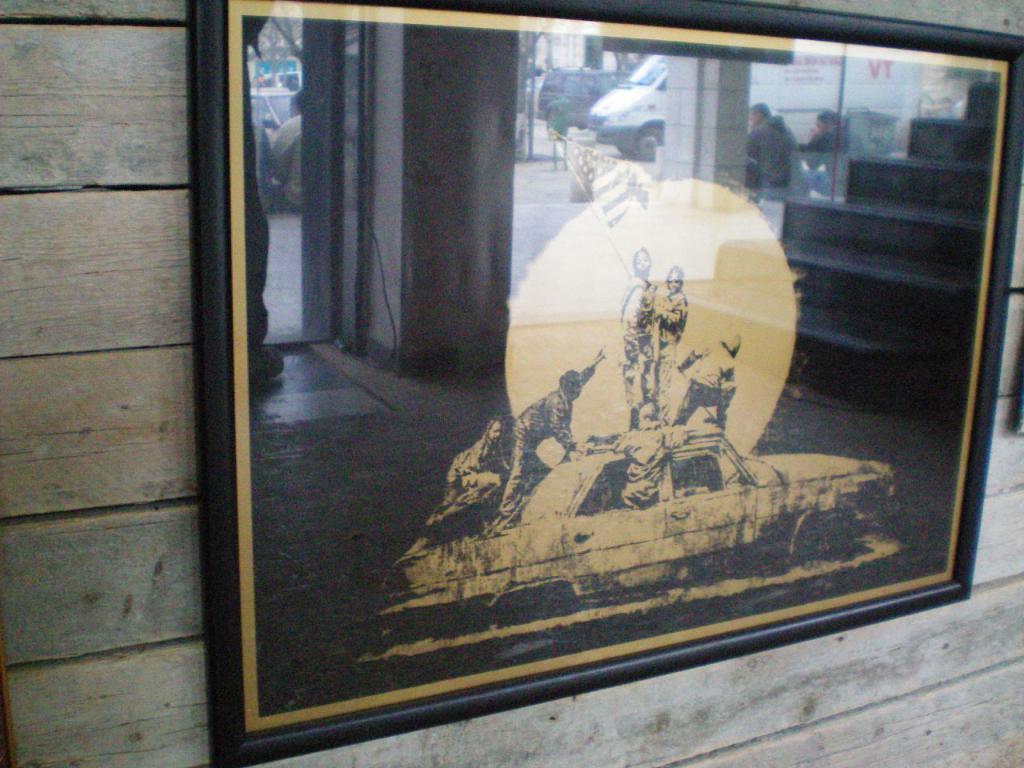Can you describe this image briefly? In this image we can see some painting attached to the wall and the painting is of a car on which there are some persons standing, holding flag in their hands. 